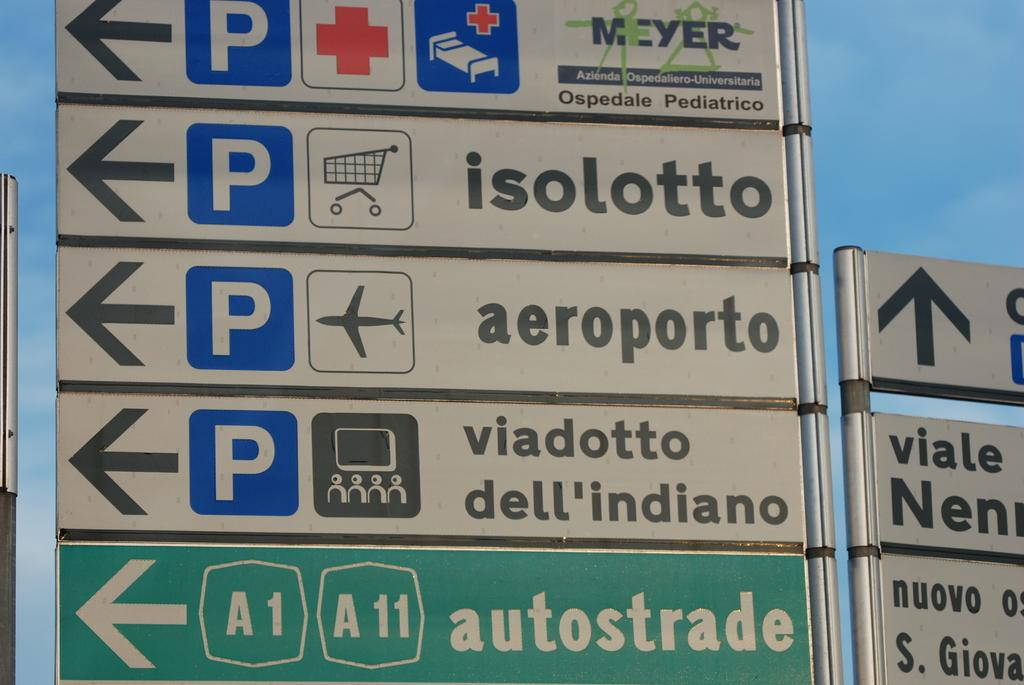<image>
Relay a brief, clear account of the picture shown. Green sign with an arrow and the word "autostade" on it. 